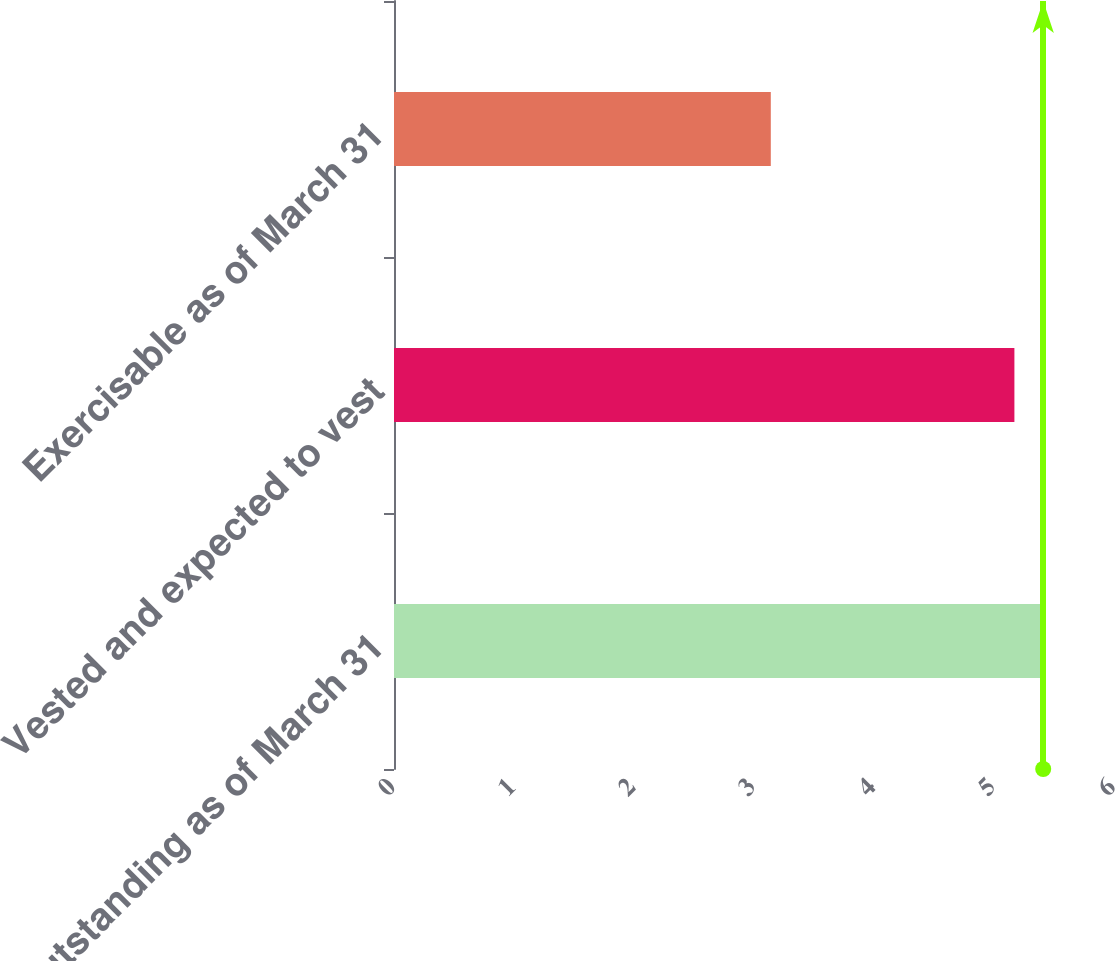Convert chart to OTSL. <chart><loc_0><loc_0><loc_500><loc_500><bar_chart><fcel>Outstanding as of March 31<fcel>Vested and expected to vest<fcel>Exercisable as of March 31<nl><fcel>5.41<fcel>5.17<fcel>3.14<nl></chart> 